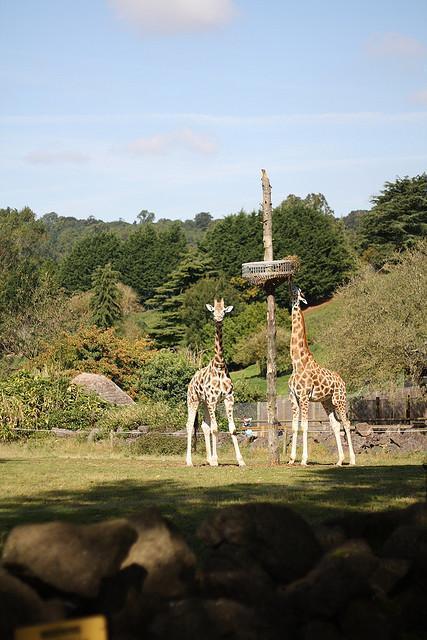How many animals are pictured?
Give a very brief answer. 2. How many giraffes are there?
Give a very brief answer. 2. 